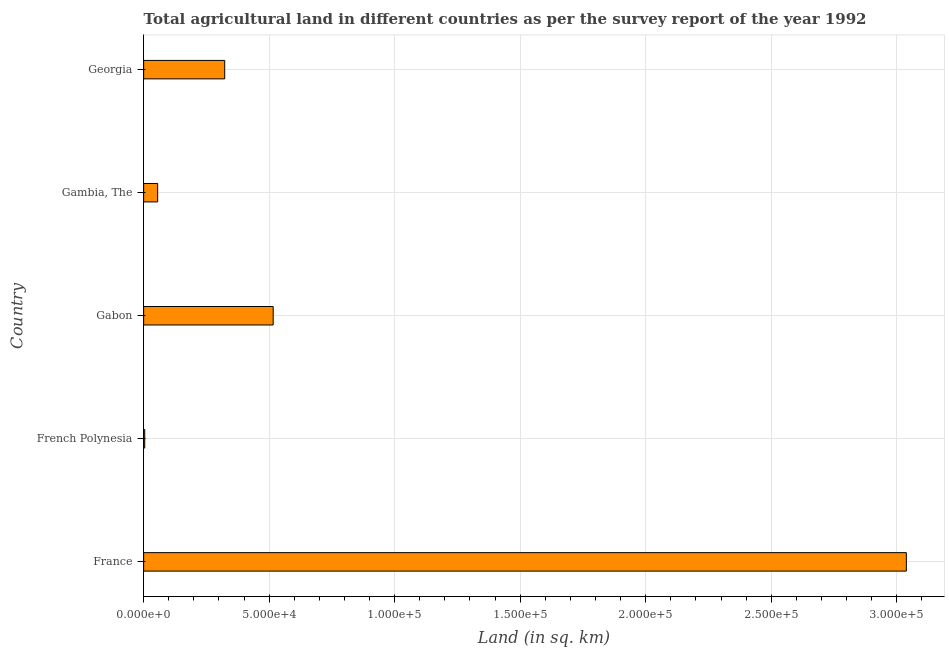Does the graph contain grids?
Your answer should be compact. Yes. What is the title of the graph?
Make the answer very short. Total agricultural land in different countries as per the survey report of the year 1992. What is the label or title of the X-axis?
Your answer should be very brief. Land (in sq. km). What is the agricultural land in Gabon?
Provide a succinct answer. 5.16e+04. Across all countries, what is the maximum agricultural land?
Your answer should be compact. 3.04e+05. Across all countries, what is the minimum agricultural land?
Provide a short and direct response. 430. In which country was the agricultural land maximum?
Make the answer very short. France. In which country was the agricultural land minimum?
Offer a terse response. French Polynesia. What is the sum of the agricultural land?
Make the answer very short. 3.94e+05. What is the difference between the agricultural land in French Polynesia and Gambia, The?
Give a very brief answer. -5150. What is the average agricultural land per country?
Provide a short and direct response. 7.87e+04. What is the median agricultural land?
Ensure brevity in your answer.  3.23e+04. In how many countries, is the agricultural land greater than 170000 sq. km?
Ensure brevity in your answer.  1. What is the ratio of the agricultural land in France to that in Georgia?
Offer a very short reply. 9.41. Is the agricultural land in France less than that in Gambia, The?
Provide a short and direct response. No. What is the difference between the highest and the second highest agricultural land?
Ensure brevity in your answer.  2.52e+05. What is the difference between the highest and the lowest agricultural land?
Offer a terse response. 3.03e+05. In how many countries, is the agricultural land greater than the average agricultural land taken over all countries?
Your answer should be compact. 1. Are all the bars in the graph horizontal?
Your answer should be compact. Yes. What is the difference between two consecutive major ticks on the X-axis?
Make the answer very short. 5.00e+04. What is the Land (in sq. km) in France?
Give a very brief answer. 3.04e+05. What is the Land (in sq. km) of French Polynesia?
Your answer should be compact. 430. What is the Land (in sq. km) in Gabon?
Provide a succinct answer. 5.16e+04. What is the Land (in sq. km) in Gambia, The?
Offer a terse response. 5580. What is the Land (in sq. km) in Georgia?
Offer a very short reply. 3.23e+04. What is the difference between the Land (in sq. km) in France and French Polynesia?
Provide a short and direct response. 3.03e+05. What is the difference between the Land (in sq. km) in France and Gabon?
Ensure brevity in your answer.  2.52e+05. What is the difference between the Land (in sq. km) in France and Gambia, The?
Your answer should be very brief. 2.98e+05. What is the difference between the Land (in sq. km) in France and Georgia?
Give a very brief answer. 2.72e+05. What is the difference between the Land (in sq. km) in French Polynesia and Gabon?
Your response must be concise. -5.12e+04. What is the difference between the Land (in sq. km) in French Polynesia and Gambia, The?
Offer a terse response. -5150. What is the difference between the Land (in sq. km) in French Polynesia and Georgia?
Your answer should be compact. -3.19e+04. What is the difference between the Land (in sq. km) in Gabon and Gambia, The?
Keep it short and to the point. 4.60e+04. What is the difference between the Land (in sq. km) in Gabon and Georgia?
Offer a very short reply. 1.93e+04. What is the difference between the Land (in sq. km) in Gambia, The and Georgia?
Keep it short and to the point. -2.67e+04. What is the ratio of the Land (in sq. km) in France to that in French Polynesia?
Make the answer very short. 706.61. What is the ratio of the Land (in sq. km) in France to that in Gabon?
Give a very brief answer. 5.89. What is the ratio of the Land (in sq. km) in France to that in Gambia, The?
Offer a very short reply. 54.45. What is the ratio of the Land (in sq. km) in France to that in Georgia?
Offer a very short reply. 9.41. What is the ratio of the Land (in sq. km) in French Polynesia to that in Gabon?
Your answer should be compact. 0.01. What is the ratio of the Land (in sq. km) in French Polynesia to that in Gambia, The?
Your answer should be very brief. 0.08. What is the ratio of the Land (in sq. km) in French Polynesia to that in Georgia?
Offer a very short reply. 0.01. What is the ratio of the Land (in sq. km) in Gabon to that in Gambia, The?
Give a very brief answer. 9.25. What is the ratio of the Land (in sq. km) in Gabon to that in Georgia?
Make the answer very short. 1.6. What is the ratio of the Land (in sq. km) in Gambia, The to that in Georgia?
Give a very brief answer. 0.17. 